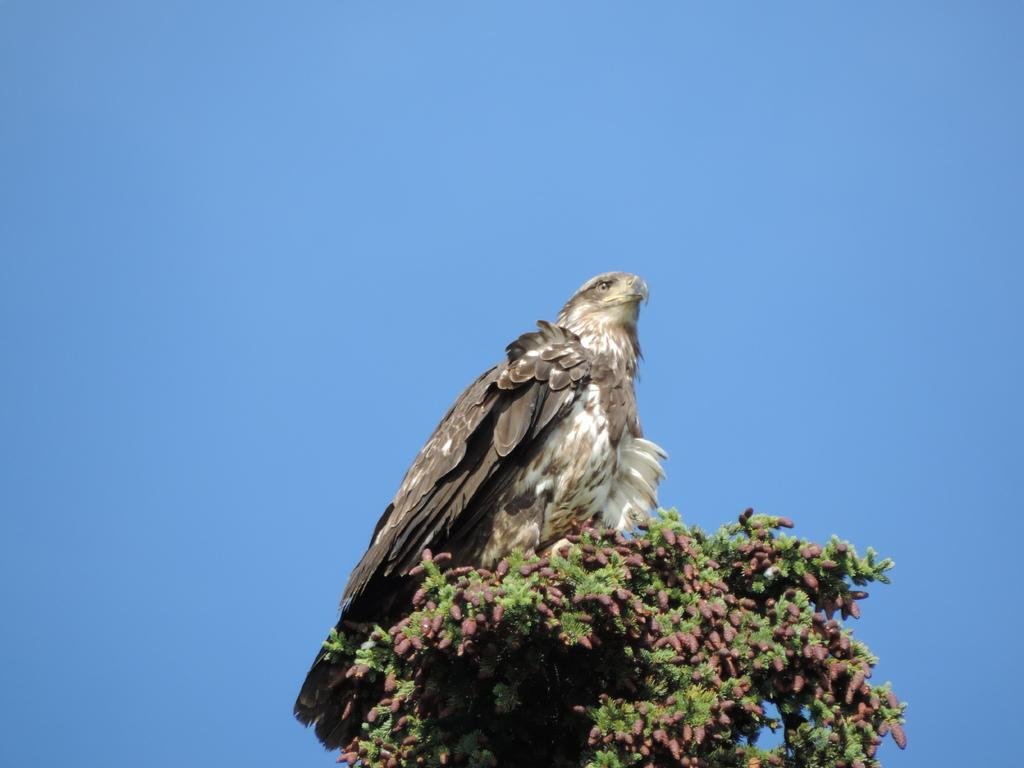What type of animal can be seen in the image? There is a bird in the image. Where is the bird located? The bird is on a tree. What can be seen in the foreground of the image? There are flowers in the foreground of the image. What is visible in the background of the image? The sky is visible in the image. What is the bird's desire in the image? There is no information about the bird's desires in the image. --- Facts: 1. There is a car in the image. 2. The car is red. 3. The car has four wheels. 4. The car is parked on the street. Absurd Topics: unicorn, rainbow, parrot Conversation: What is the main subject in the image? There is a car in the image. What is the color of the car? The car is red. How many wheels does the car have? The car has four wheels. Where is the car located in the image? The car is parked on the street. Reasoning: Let's think step by step in order to produce the conversation. We start by identifying the main subject of the image, which is the car. Next, we describe specific features of the car, such as the color and the number of wheels. Then, we observe the location of the car in the image, noting that it is parked on the street. Finally, we ensure that the language is simple and clear. Absurd Question/Answer: Can you see a unicorn in the image? There is no unicorn present in the image. --- Facts: 1. There is a group of people in the image. 2. The people are wearing hats. 3. The people are holding hands. 4. The people are standing in front of a building. Absurd Topics: elephant, elephant trunk, elephant tusk Conversation: How many people are in the image? There is a group of people in the image. What are the people wearing on their heads? The people are wearing hats. What are the people doing in the image? The people are holding hands. What can be seen behind the people in the image? The people are standing in front of a building. Reasoning: Let's think step by step in order to produce the conversation. We start by identifying the main subject of the image, which is the group of people. Next, we describe specific features of the people, such as the hats they are wearing. Then, we observe the actions of the people in the image, noting that they are holding hands. Finally, we describe the background element visible in the image, which is a building. We ensure that the language is simple and clear. Absurd Question/Answer: Can you see an elephant trunk in the image? There is no ele 